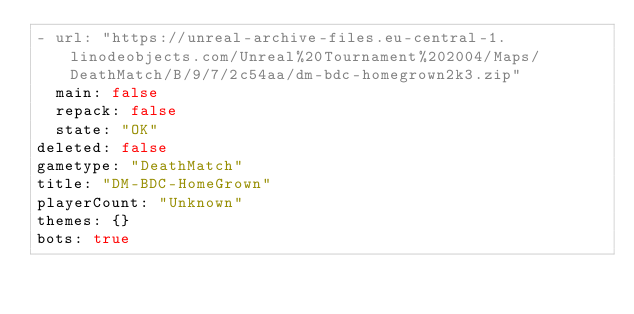Convert code to text. <code><loc_0><loc_0><loc_500><loc_500><_YAML_>- url: "https://unreal-archive-files.eu-central-1.linodeobjects.com/Unreal%20Tournament%202004/Maps/DeathMatch/B/9/7/2c54aa/dm-bdc-homegrown2k3.zip"
  main: false
  repack: false
  state: "OK"
deleted: false
gametype: "DeathMatch"
title: "DM-BDC-HomeGrown"
playerCount: "Unknown"
themes: {}
bots: true
</code> 